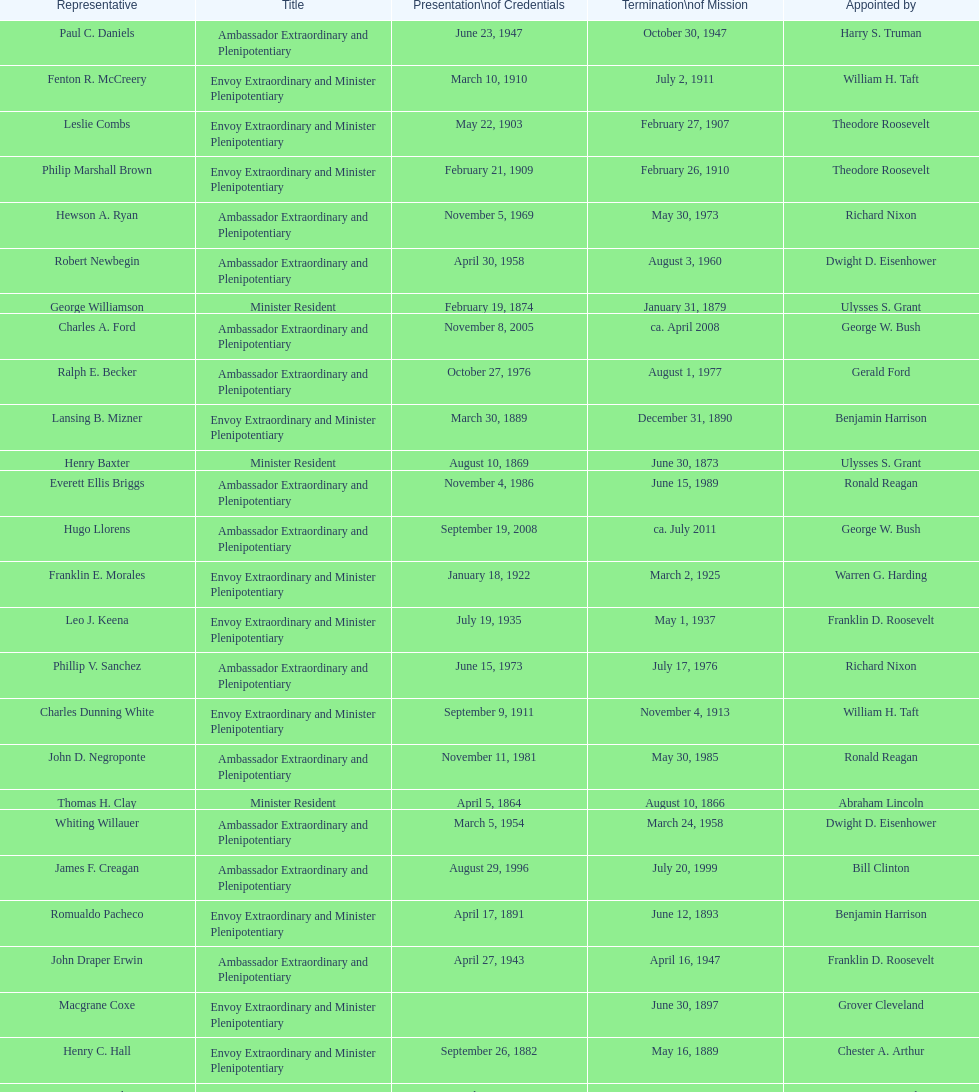Which date is below april 17, 1854 March 17, 1860. Would you be able to parse every entry in this table? {'header': ['Representative', 'Title', 'Presentation\\nof Credentials', 'Termination\\nof Mission', 'Appointed by'], 'rows': [['Paul C. Daniels', 'Ambassador Extraordinary and Plenipotentiary', 'June 23, 1947', 'October 30, 1947', 'Harry S. Truman'], ['Fenton R. McCreery', 'Envoy Extraordinary and Minister Plenipotentiary', 'March 10, 1910', 'July 2, 1911', 'William H. Taft'], ['Leslie Combs', 'Envoy Extraordinary and Minister Plenipotentiary', 'May 22, 1903', 'February 27, 1907', 'Theodore Roosevelt'], ['Philip Marshall Brown', 'Envoy Extraordinary and Minister Plenipotentiary', 'February 21, 1909', 'February 26, 1910', 'Theodore Roosevelt'], ['Hewson A. Ryan', 'Ambassador Extraordinary and Plenipotentiary', 'November 5, 1969', 'May 30, 1973', 'Richard Nixon'], ['Robert Newbegin', 'Ambassador Extraordinary and Plenipotentiary', 'April 30, 1958', 'August 3, 1960', 'Dwight D. Eisenhower'], ['George Williamson', 'Minister Resident', 'February 19, 1874', 'January 31, 1879', 'Ulysses S. Grant'], ['Charles A. Ford', 'Ambassador Extraordinary and Plenipotentiary', 'November 8, 2005', 'ca. April 2008', 'George W. Bush'], ['Ralph E. Becker', 'Ambassador Extraordinary and Plenipotentiary', 'October 27, 1976', 'August 1, 1977', 'Gerald Ford'], ['Lansing B. Mizner', 'Envoy Extraordinary and Minister Plenipotentiary', 'March 30, 1889', 'December 31, 1890', 'Benjamin Harrison'], ['Henry Baxter', 'Minister Resident', 'August 10, 1869', 'June 30, 1873', 'Ulysses S. Grant'], ['Everett Ellis Briggs', 'Ambassador Extraordinary and Plenipotentiary', 'November 4, 1986', 'June 15, 1989', 'Ronald Reagan'], ['Hugo Llorens', 'Ambassador Extraordinary and Plenipotentiary', 'September 19, 2008', 'ca. July 2011', 'George W. Bush'], ['Franklin E. Morales', 'Envoy Extraordinary and Minister Plenipotentiary', 'January 18, 1922', 'March 2, 1925', 'Warren G. Harding'], ['Leo J. Keena', 'Envoy Extraordinary and Minister Plenipotentiary', 'July 19, 1935', 'May 1, 1937', 'Franklin D. Roosevelt'], ['Phillip V. Sanchez', 'Ambassador Extraordinary and Plenipotentiary', 'June 15, 1973', 'July 17, 1976', 'Richard Nixon'], ['Charles Dunning White', 'Envoy Extraordinary and Minister Plenipotentiary', 'September 9, 1911', 'November 4, 1913', 'William H. Taft'], ['John D. Negroponte', 'Ambassador Extraordinary and Plenipotentiary', 'November 11, 1981', 'May 30, 1985', 'Ronald Reagan'], ['Thomas H. Clay', 'Minister Resident', 'April 5, 1864', 'August 10, 1866', 'Abraham Lincoln'], ['Whiting Willauer', 'Ambassador Extraordinary and Plenipotentiary', 'March 5, 1954', 'March 24, 1958', 'Dwight D. Eisenhower'], ['James F. Creagan', 'Ambassador Extraordinary and Plenipotentiary', 'August 29, 1996', 'July 20, 1999', 'Bill Clinton'], ['Romualdo Pacheco', 'Envoy Extraordinary and Minister Plenipotentiary', 'April 17, 1891', 'June 12, 1893', 'Benjamin Harrison'], ['John Draper Erwin', 'Ambassador Extraordinary and Plenipotentiary', 'April 27, 1943', 'April 16, 1947', 'Franklin D. Roosevelt'], ['Macgrane Coxe', 'Envoy Extraordinary and Minister Plenipotentiary', '', 'June 30, 1897', 'Grover Cleveland'], ['Henry C. Hall', 'Envoy Extraordinary and Minister Plenipotentiary', 'September 26, 1882', 'May 16, 1889', 'Chester A. Arthur'], ['Larry Leon Palmer', 'Ambassador Extraordinary and Plenipotentiary', 'October 8, 2002', 'May 7, 2005', 'George W. Bush'], ['Herbert S. Bursley', 'Ambassador Extraordinary and Plenipotentiary', 'May 15, 1948', 'December 12, 1950', 'Harry S. Truman'], ['John Draper Erwin', 'Envoy Extraordinary and Minister Plenipotentiary', 'September 8, 1937', 'April 27, 1943', 'Franklin D. Roosevelt'], ['George T. Summerlin', 'Envoy Extraordinary and Minister Plenipotentiary', 'November 21, 1925', 'December 17, 1929', 'Calvin Coolidge'], ['John Ewing', 'Envoy Extraordinary and Minister Plenipotentiary', 'December 26, 1913', 'January 18, 1918', 'Woodrow Wilson'], ['Beverly L. Clarke', 'Minister Resident', 'August 10, 1858', 'March 17, 1860', 'James Buchanan'], ['Solon Borland', 'Envoy Extraordinary and Minister Plenipotentiary', '', 'April 17, 1854', 'Franklin Pierce'], ['Joseph J. Jova', 'Ambassador Extraordinary and Plenipotentiary', 'July 12, 1965', 'June 21, 1969', 'Lyndon B. Johnson'], ['Mari-Luci Jaramillo', 'Ambassador Extraordinary and Plenipotentiary', 'October 27, 1977', 'September 19, 1980', 'Jimmy Carter'], ['Lisa Kubiske', 'Ambassador Extraordinary and Plenipotentiary', 'July 26, 2011', 'Incumbent', 'Barack Obama'], ['Cresencio S. Arcos, Jr.', 'Ambassador Extraordinary and Plenipotentiary', 'January 29, 1990', 'July 1, 1993', 'George H. W. Bush'], ['Richard H. Rousseau', 'Minister Resident', 'October 10, 1866', 'August 10, 1869', 'Andrew Johnson'], ['Henry C. Hall', 'Minister Resident', 'April 21, 1882', 'September 26, 1882', 'Chester A. Arthur'], ['Jack R. Binns', 'Ambassador Extraordinary and Plenipotentiary', 'October 10, 1980', 'October 31, 1981', 'Jimmy Carter'], ['Frank Almaguer', 'Ambassador Extraordinary and Plenipotentiary', 'August 25, 1999', 'September 5, 2002', 'Bill Clinton'], ['Julius G. Lay', 'Envoy Extraordinary and Minister Plenipotentiary', 'May 31, 1930', 'March 17, 1935', 'Herbert Hoover'], ['James R. Partridge', 'Minister Resident', 'April 25, 1862', 'November 14, 1862', 'Abraham Lincoln'], ['Cornelius A. Logan', 'Minister Resident', 'October 10, 1879', 'April 15, 1882', 'Rutherford B. Hayes'], ['W. Godfrey Hunter', 'Envoy Extraordinary and Minister Plenipotentiary', 'January 19, 1899', 'February 2, 1903', 'William McKinley'], ['John Arthur Ferch', 'Ambassador Extraordinary and Plenipotentiary', 'August 22, 1985', 'July 9, 1986', 'Ronald Reagan'], ['H. Percival Dodge', 'Envoy Extraordinary and Minister Plenipotentiary', 'June 17, 1908', 'February 6, 1909', 'Theodore Roosevelt'], ['Charles R. Burrows', 'Ambassador Extraordinary and Plenipotentiary', 'November 3, 1960', 'June 28, 1965', 'Dwight D. Eisenhower'], ['John Draper Erwin', 'Ambassador Extraordinary and Plenipotentiary', 'March 14, 1951', 'February 28, 1954', 'Harry S. Truman'], ['Joseph W. J. Lee', 'Envoy Extraordinary and Minister Plenipotentiary', '', 'July 1, 1907', 'Theodore Roosevelt'], ['T. Sambola Jones', 'Envoy Extraordinary and Minister Plenipotentiary', 'October 2, 1918', 'October 17, 1919', 'Woodrow Wilson'], ['William Thornton Pryce', 'Ambassador Extraordinary and Plenipotentiary', 'July 21, 1993', 'August 15, 1996', 'Bill Clinton'], ['Pierce M. B. Young', 'Envoy Extraordinary and Minister Plenipotentiary', 'November 12, 1893', 'May 23, 1896', 'Grover Cleveland']]} 